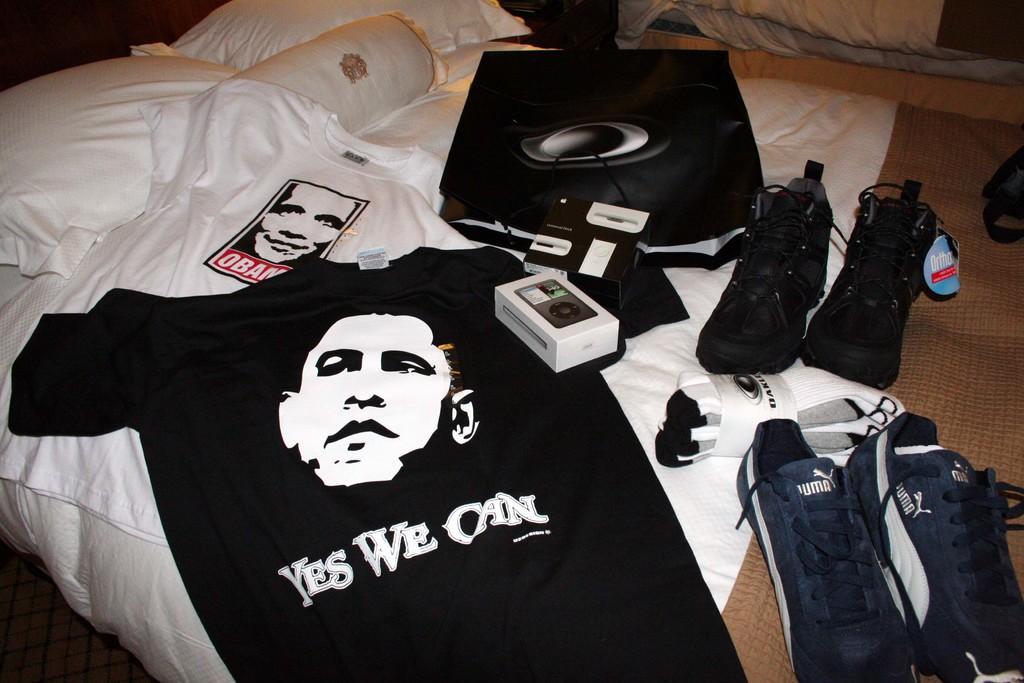Could you give a brief overview of what you see in this image? In this image we can see a bed with pillows. On the bed there are t shirts, shoes, socks, box and many other items. 